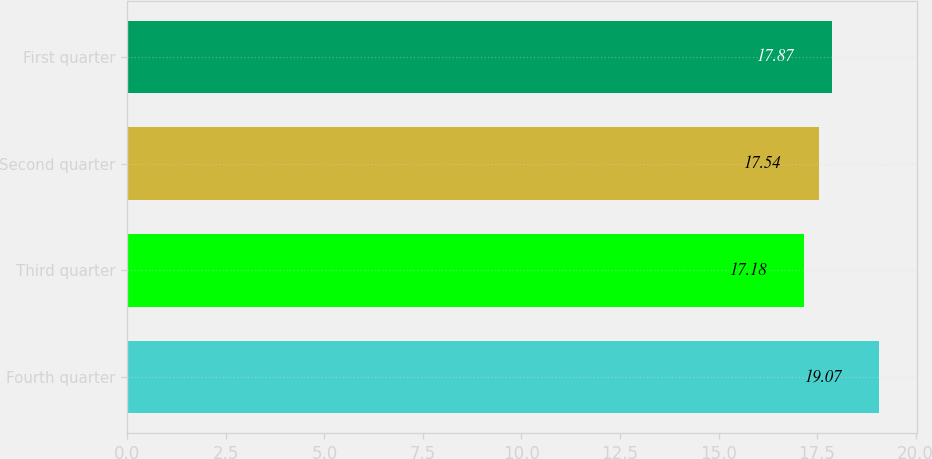<chart> <loc_0><loc_0><loc_500><loc_500><bar_chart><fcel>Fourth quarter<fcel>Third quarter<fcel>Second quarter<fcel>First quarter<nl><fcel>19.07<fcel>17.18<fcel>17.54<fcel>17.87<nl></chart> 